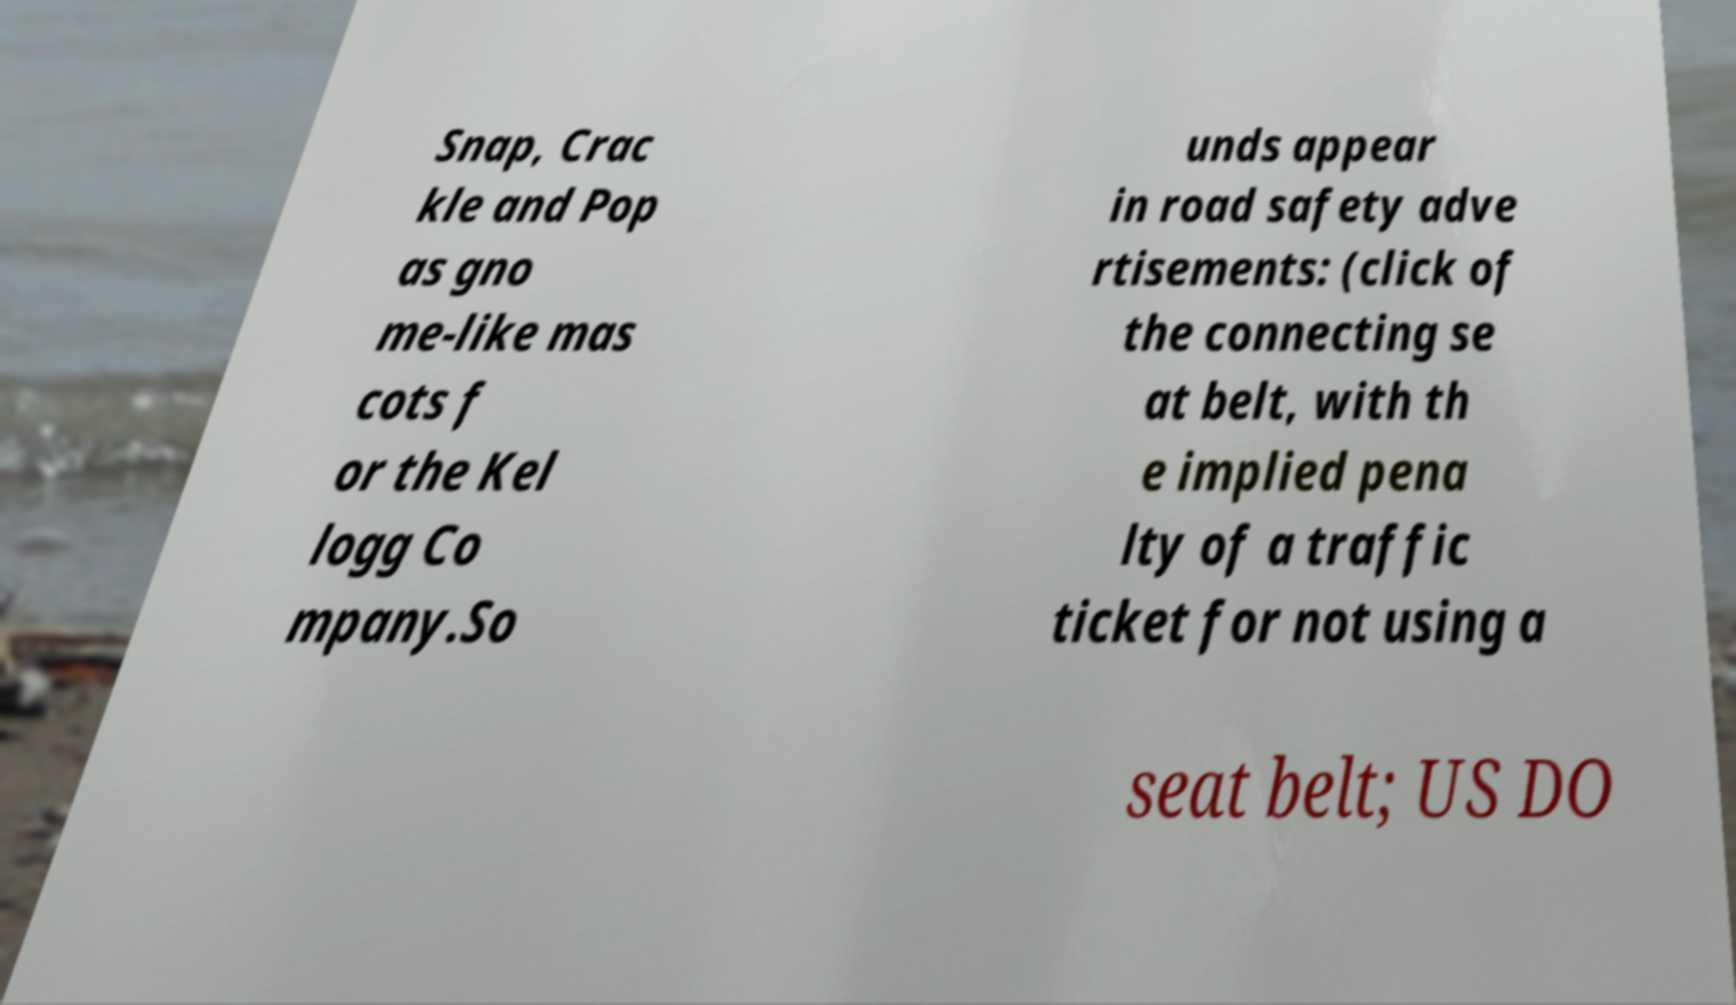I need the written content from this picture converted into text. Can you do that? Snap, Crac kle and Pop as gno me-like mas cots f or the Kel logg Co mpany.So unds appear in road safety adve rtisements: (click of the connecting se at belt, with th e implied pena lty of a traffic ticket for not using a seat belt; US DO 